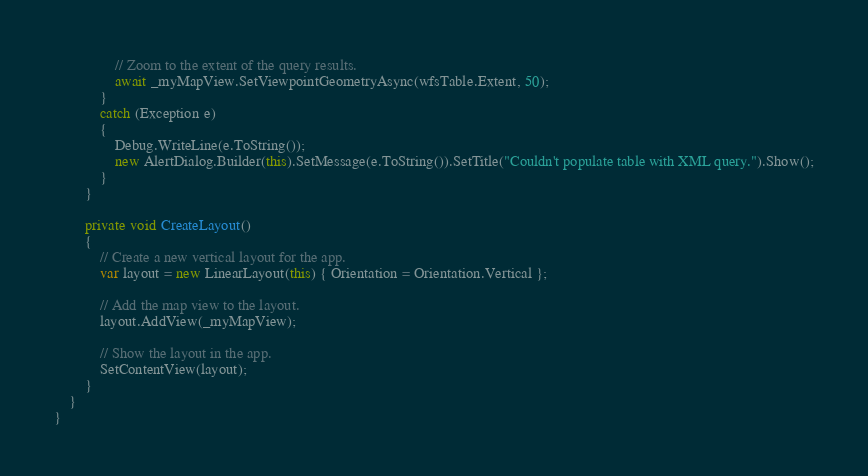<code> <loc_0><loc_0><loc_500><loc_500><_C#_>                // Zoom to the extent of the query results.
                await _myMapView.SetViewpointGeometryAsync(wfsTable.Extent, 50);
            }
            catch (Exception e)
            {
                Debug.WriteLine(e.ToString());
                new AlertDialog.Builder(this).SetMessage(e.ToString()).SetTitle("Couldn't populate table with XML query.").Show();
            }
        }

        private void CreateLayout()
        {
            // Create a new vertical layout for the app.
            var layout = new LinearLayout(this) { Orientation = Orientation.Vertical };

            // Add the map view to the layout.
            layout.AddView(_myMapView);

            // Show the layout in the app.
            SetContentView(layout);
        }
    }
}
</code> 